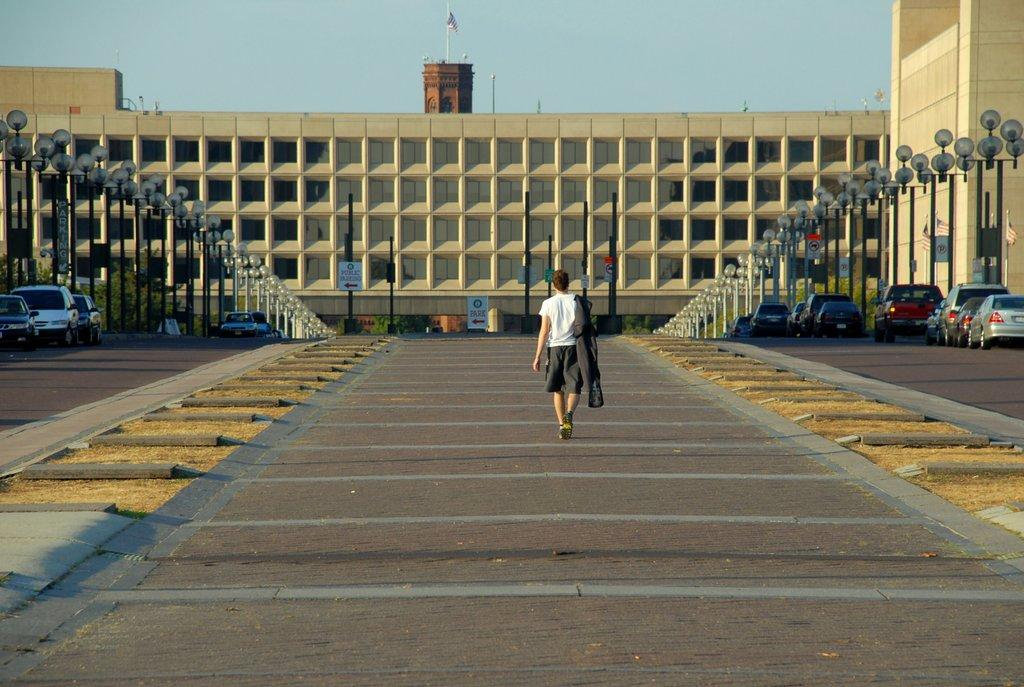What is the person in the image doing? There is a person walking in the image. On what surface is the person walking? The person is walking on the floor. What type of structures can be seen in the image? There are buildings in the image. What are some other objects present in the image? Street poles, street lights, sign boards, motor vehicles, a flag, and a flag post are visible in the image. What part of the natural environment is visible in the image? The sky is visible in the image. What type of rod is the person using to walk in the image? There is no rod present in the image; the person is walking without any assistance. How many thumbs does the person have in the image? The image does not show the person's hands, so it is impossible to determine the number of thumbs they have. What flavor of mint can be seen in the image? There is no mint present in the image. 